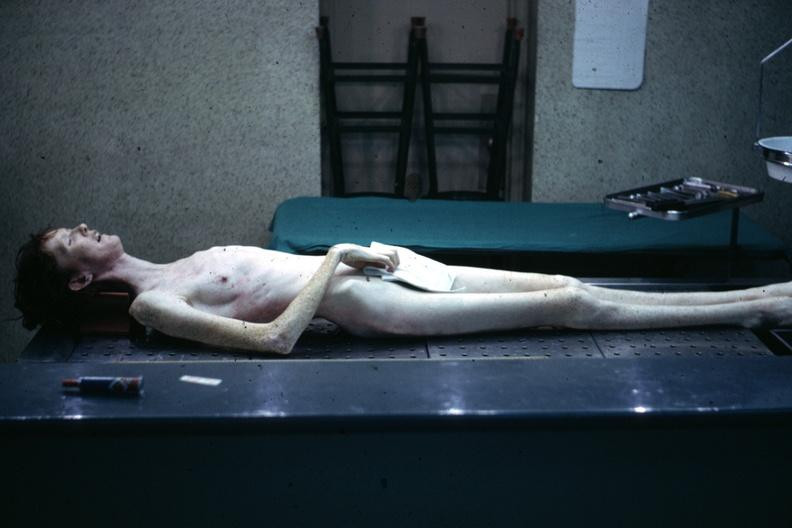what is present?
Answer the question using a single word or phrase. Marfans syndrome 